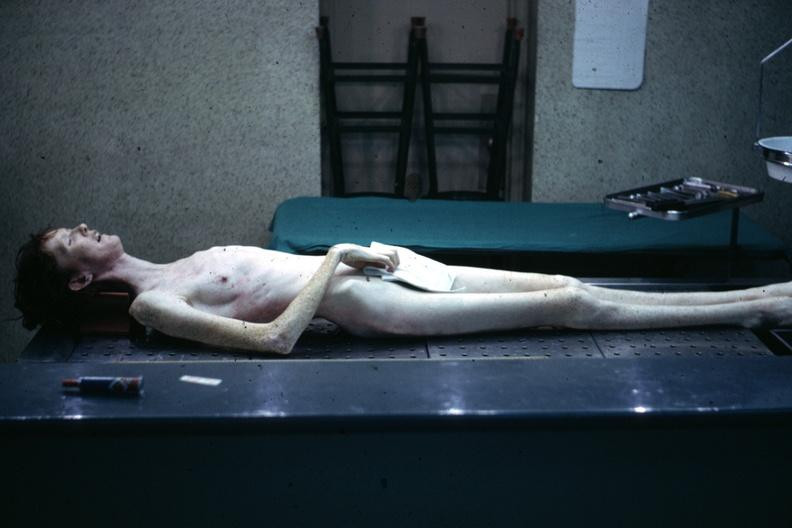what is present?
Answer the question using a single word or phrase. Marfans syndrome 